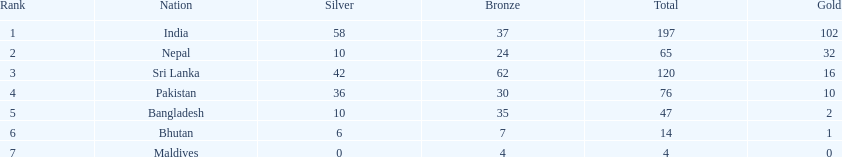What was the number of silver medals won by pakistan? 36. 